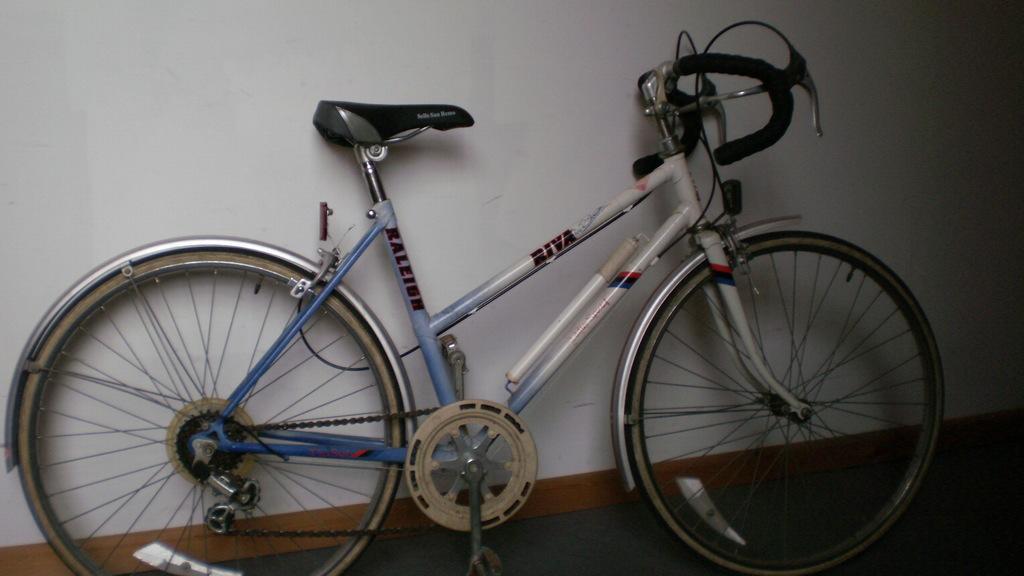Describe this image in one or two sentences. This image consists of a bicycle is kept in a room. In the background, there is a wall in white color. At the bottom, there is a floor. 